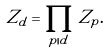Convert formula to latex. <formula><loc_0><loc_0><loc_500><loc_500>Z _ { d } = \prod _ { p | d } Z _ { p } .</formula> 